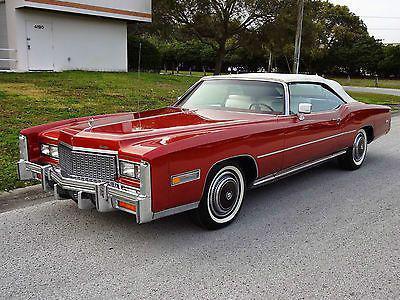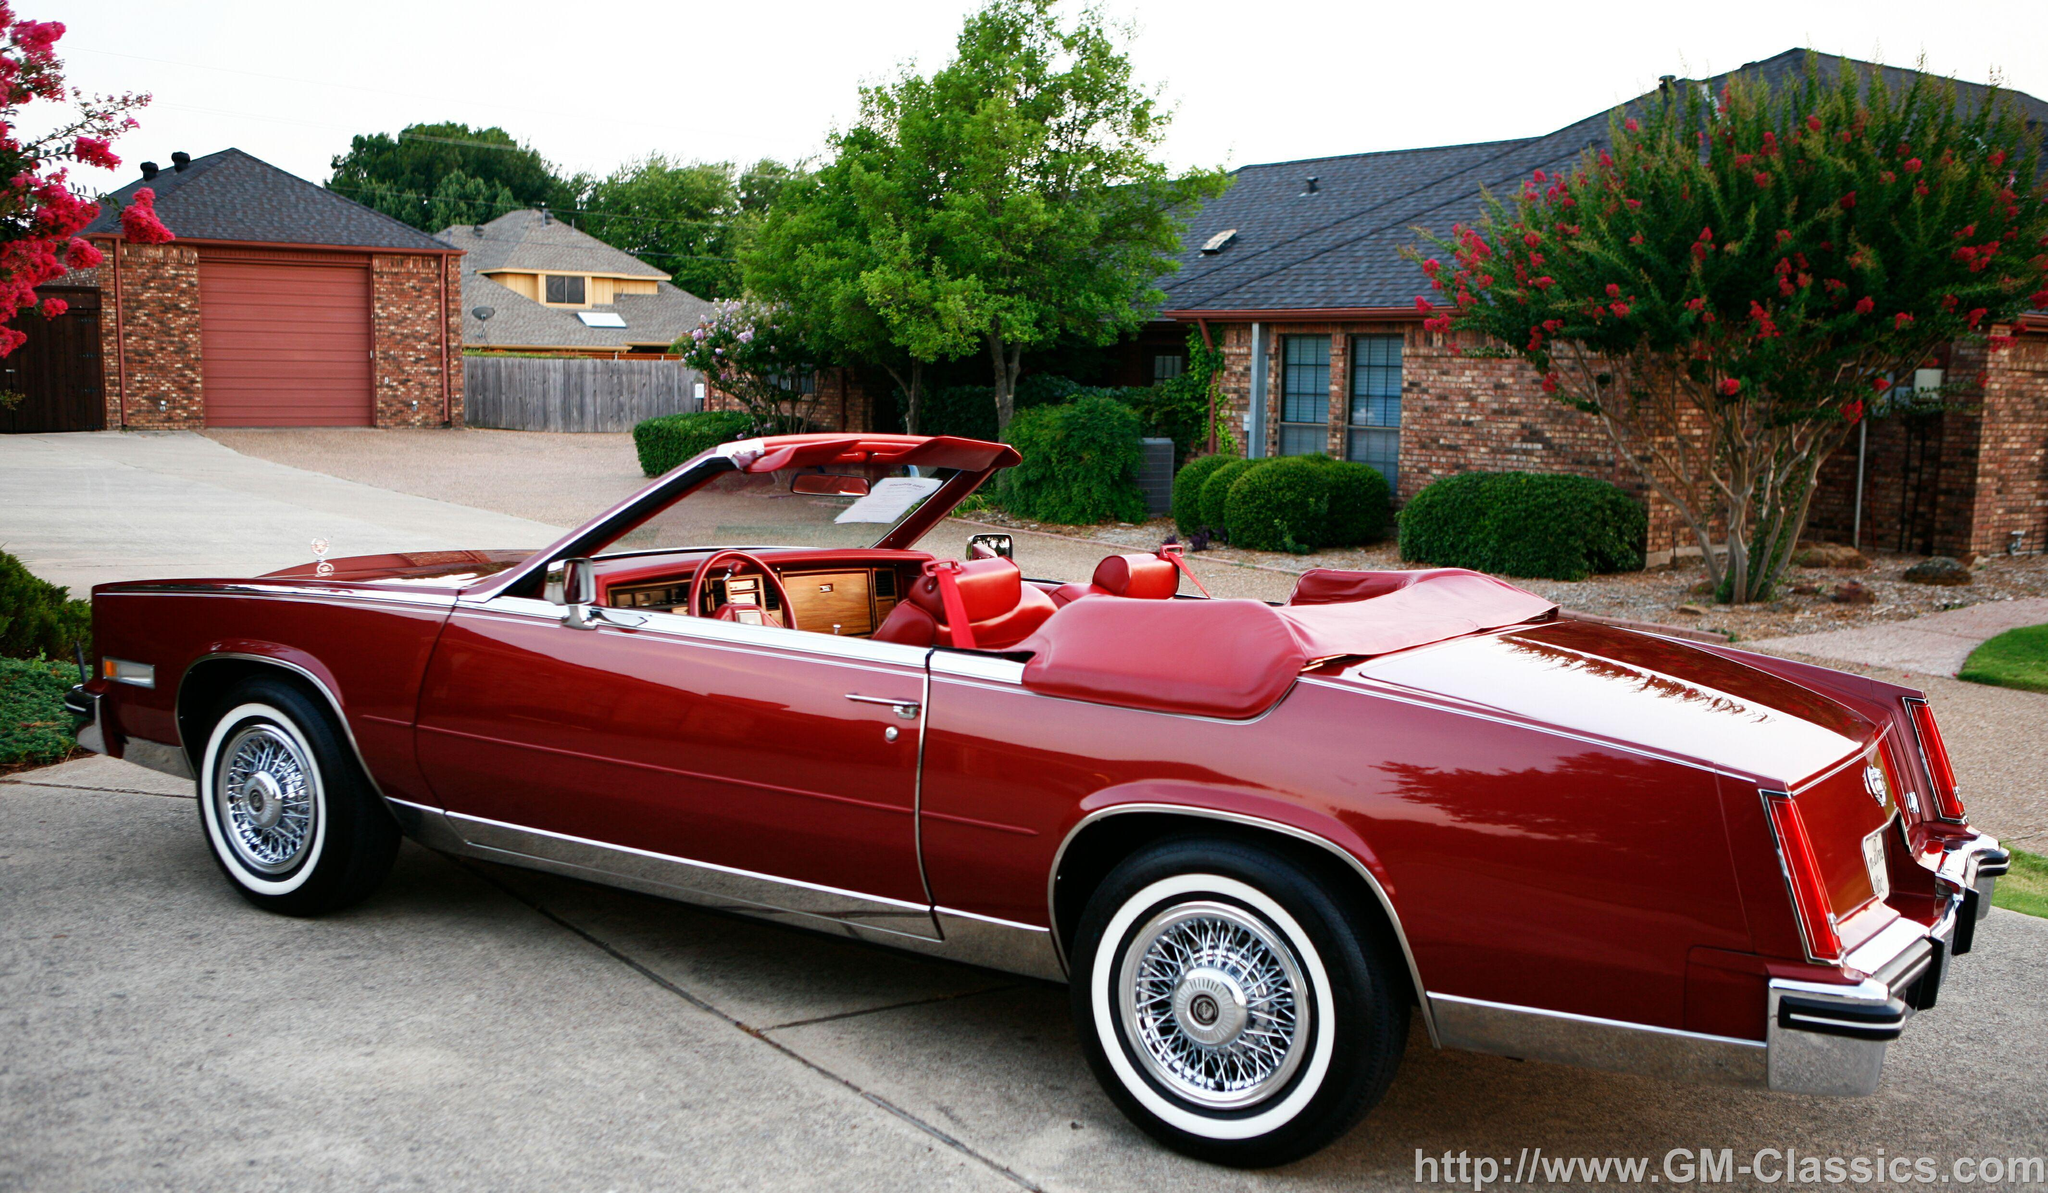The first image is the image on the left, the second image is the image on the right. Evaluate the accuracy of this statement regarding the images: "The car in the image on the left has its top up.". Is it true? Answer yes or no. Yes. The first image is the image on the left, the second image is the image on the right. Considering the images on both sides, is "One image shows a red soft-topped vintage car with missile-like red lights and jutting fins, and the other image shows a red topless vintage convertible." valid? Answer yes or no. No. 